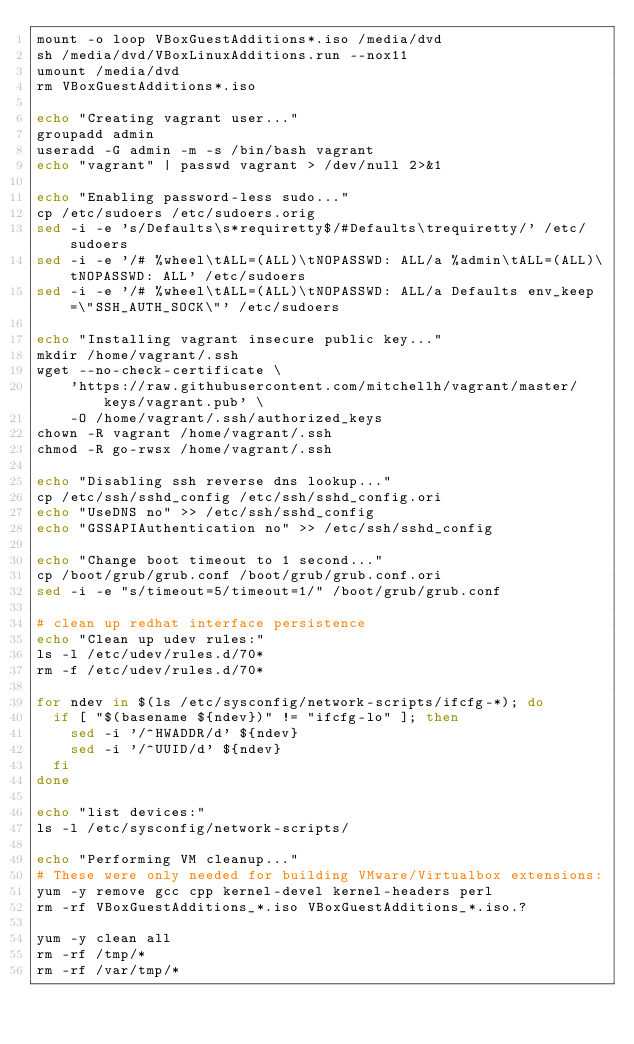<code> <loc_0><loc_0><loc_500><loc_500><_Bash_>mount -o loop VBoxGuestAdditions*.iso /media/dvd
sh /media/dvd/VBoxLinuxAdditions.run --nox11
umount /media/dvd
rm VBoxGuestAdditions*.iso

echo "Creating vagrant user..."
groupadd admin
useradd -G admin -m -s /bin/bash vagrant
echo "vagrant" | passwd vagrant > /dev/null 2>&1

echo "Enabling password-less sudo..."
cp /etc/sudoers /etc/sudoers.orig
sed -i -e 's/Defaults\s*requiretty$/#Defaults\trequiretty/' /etc/sudoers
sed -i -e '/# %wheel\tALL=(ALL)\tNOPASSWD: ALL/a %admin\tALL=(ALL)\tNOPASSWD: ALL' /etc/sudoers
sed -i -e '/# %wheel\tALL=(ALL)\tNOPASSWD: ALL/a Defaults env_keep=\"SSH_AUTH_SOCK\"' /etc/sudoers

echo "Installing vagrant insecure public key..."
mkdir /home/vagrant/.ssh
wget --no-check-certificate \
    'https://raw.githubusercontent.com/mitchellh/vagrant/master/keys/vagrant.pub' \
    -O /home/vagrant/.ssh/authorized_keys
chown -R vagrant /home/vagrant/.ssh
chmod -R go-rwsx /home/vagrant/.ssh

echo "Disabling ssh reverse dns lookup..."
cp /etc/ssh/sshd_config /etc/ssh/sshd_config.ori
echo "UseDNS no" >> /etc/ssh/sshd_config
echo "GSSAPIAuthentication no" >> /etc/ssh/sshd_config

echo "Change boot timeout to 1 second..."
cp /boot/grub/grub.conf /boot/grub/grub.conf.ori
sed -i -e "s/timeout=5/timeout=1/" /boot/grub/grub.conf

# clean up redhat interface persistence
echo "Clean up udev rules:"
ls -l /etc/udev/rules.d/70*
rm -f /etc/udev/rules.d/70*

for ndev in $(ls /etc/sysconfig/network-scripts/ifcfg-*); do
	if [ "$(basename ${ndev})" != "ifcfg-lo" ]; then
		sed -i '/^HWADDR/d' ${ndev}
		sed -i '/^UUID/d' ${ndev}
	fi
done

echo "list devices:"
ls -l /etc/sysconfig/network-scripts/

echo "Performing VM cleanup..."
# These were only needed for building VMware/Virtualbox extensions:
yum -y remove gcc cpp kernel-devel kernel-headers perl
rm -rf VBoxGuestAdditions_*.iso VBoxGuestAdditions_*.iso.?

yum -y clean all
rm -rf /tmp/*
rm -rf /var/tmp/*
</code> 